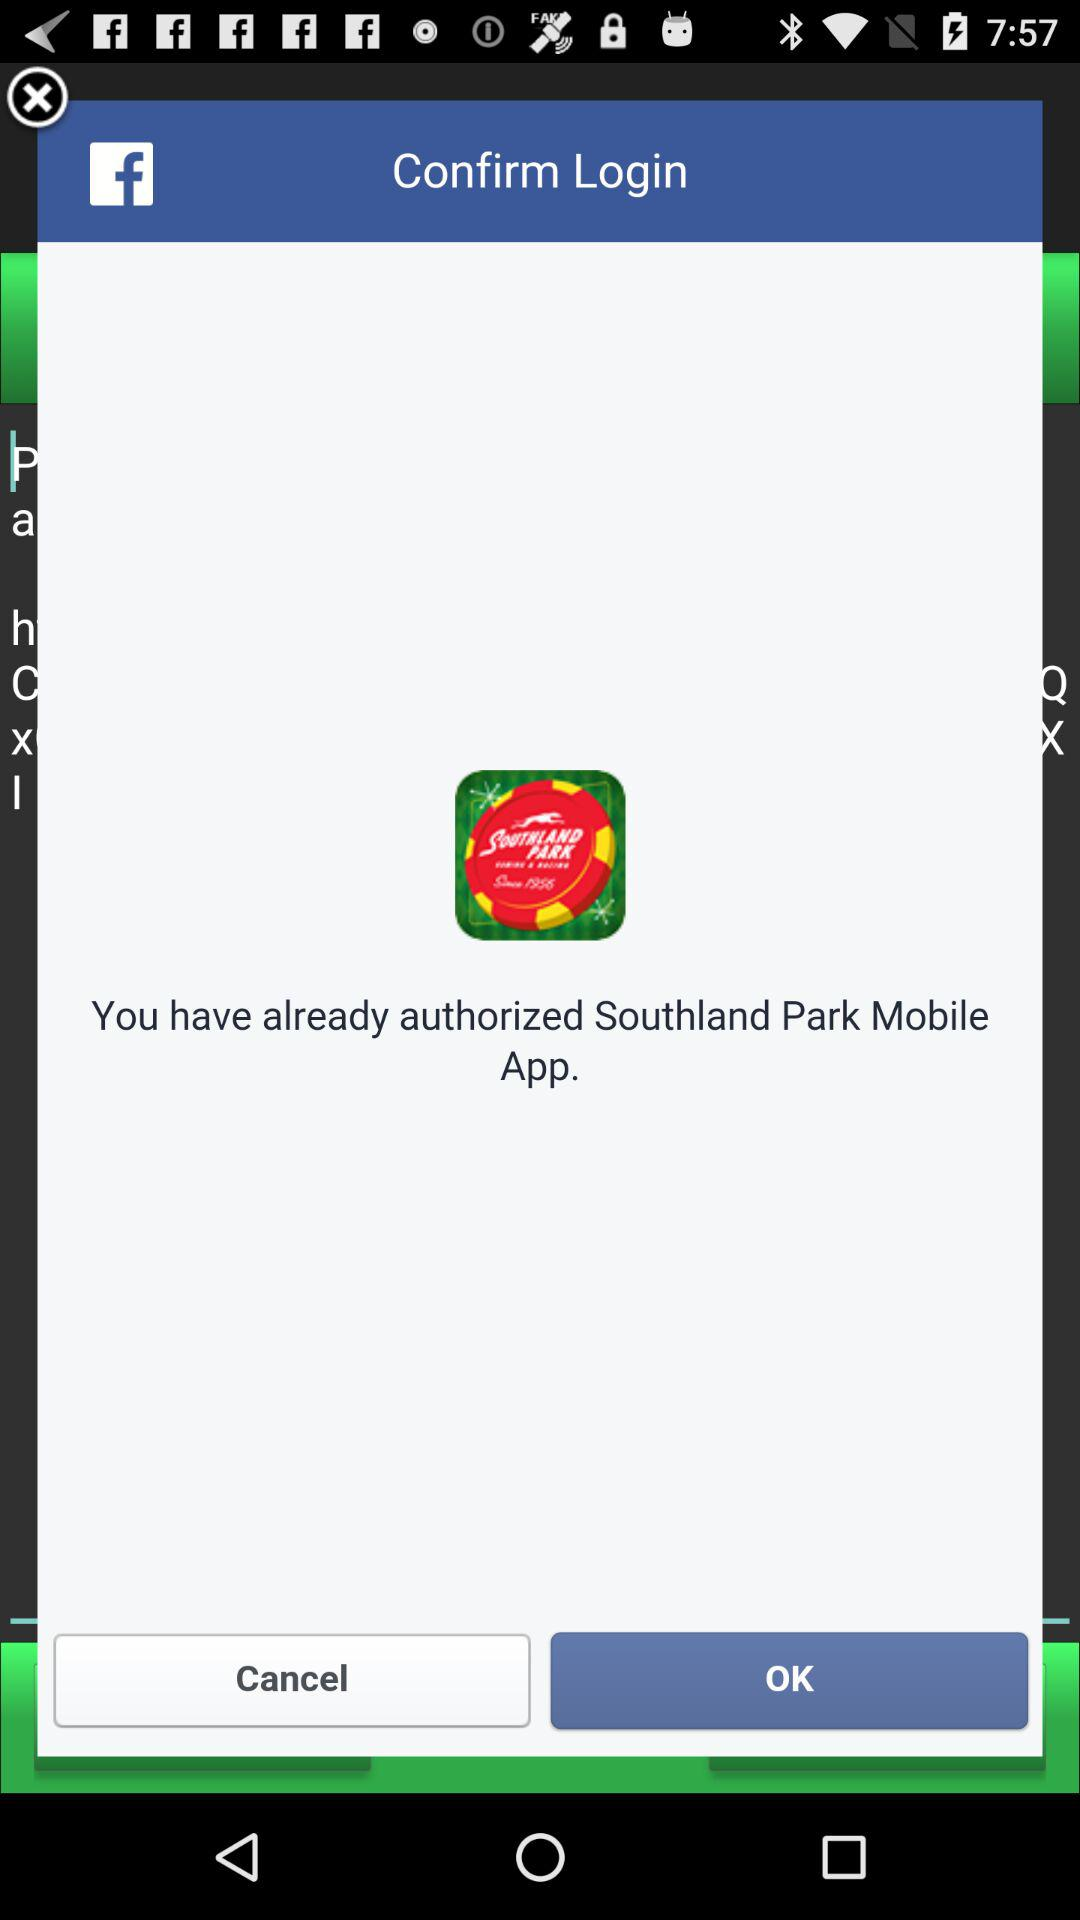When was "Southland Park Mobile App" authorized?
When the provided information is insufficient, respond with <no answer>. <no answer> 